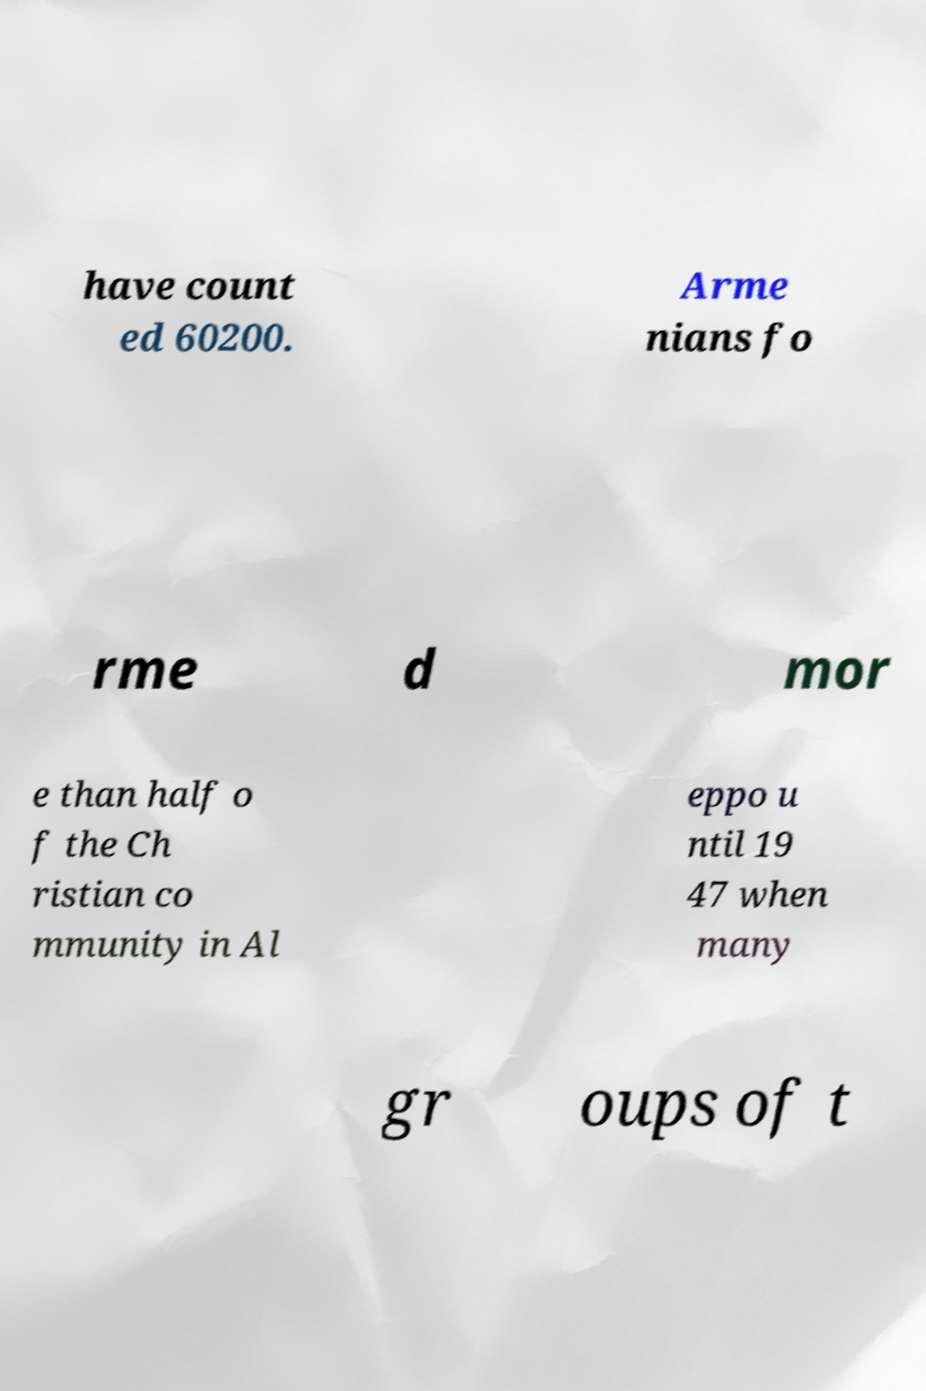Could you assist in decoding the text presented in this image and type it out clearly? have count ed 60200. Arme nians fo rme d mor e than half o f the Ch ristian co mmunity in Al eppo u ntil 19 47 when many gr oups of t 